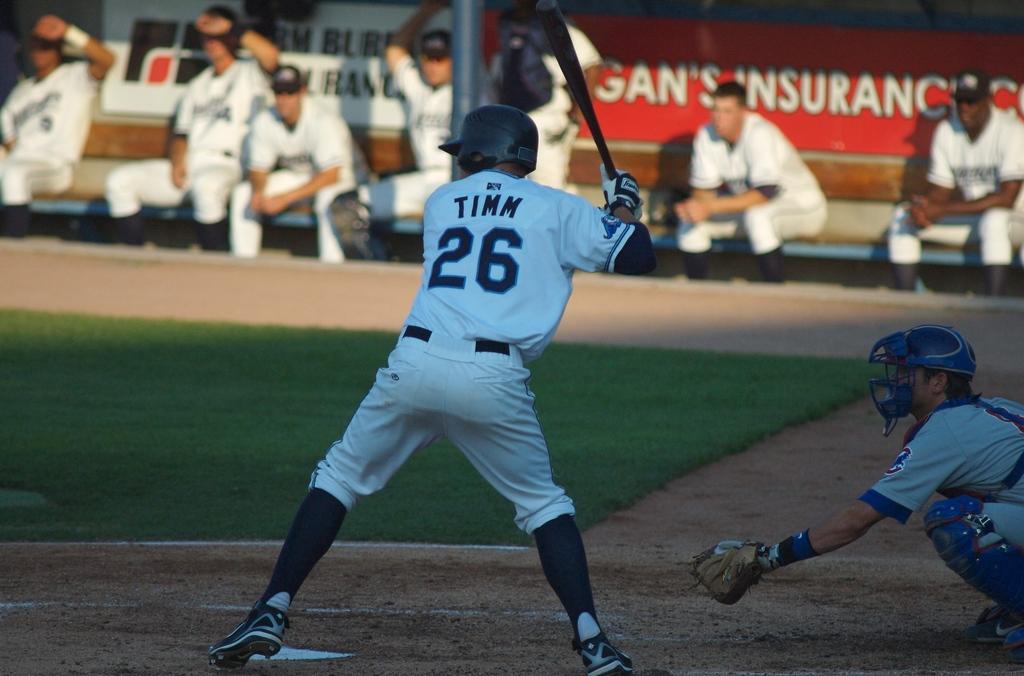What number is on the jersey?
Your answer should be compact. 26. What is the players name?
Make the answer very short. Timm. 